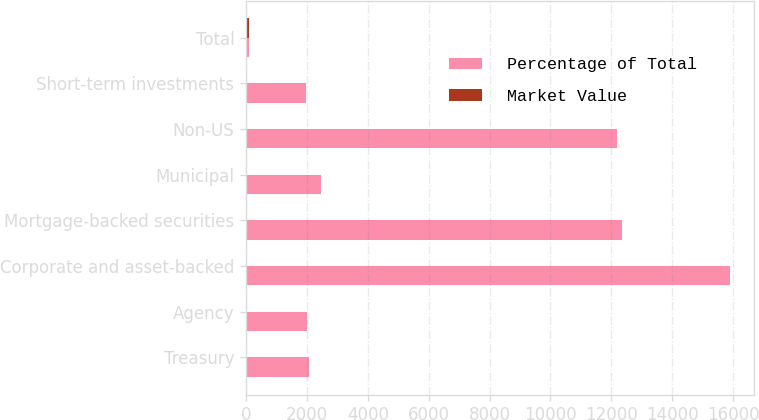<chart> <loc_0><loc_0><loc_500><loc_500><stacked_bar_chart><ecel><fcel>Treasury<fcel>Agency<fcel>Corporate and asset-backed<fcel>Mortgage-backed securities<fcel>Municipal<fcel>Non-US<fcel>Short-term investments<fcel>Total<nl><fcel>Percentage of Total<fcel>2075<fcel>2015<fcel>15900<fcel>12362<fcel>2449<fcel>12199<fcel>1983<fcel>100<nl><fcel>Market Value<fcel>4<fcel>4<fcel>33<fcel>25<fcel>5<fcel>25<fcel>4<fcel>100<nl></chart> 